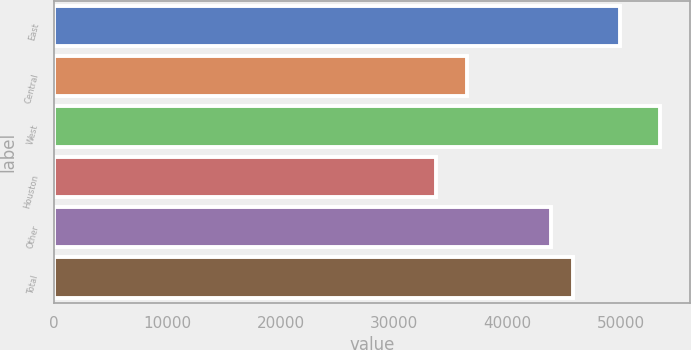<chart> <loc_0><loc_0><loc_500><loc_500><bar_chart><fcel>East<fcel>Central<fcel>West<fcel>Houston<fcel>Other<fcel>Total<nl><fcel>49900<fcel>36400<fcel>53400<fcel>33700<fcel>43800<fcel>45770<nl></chart> 